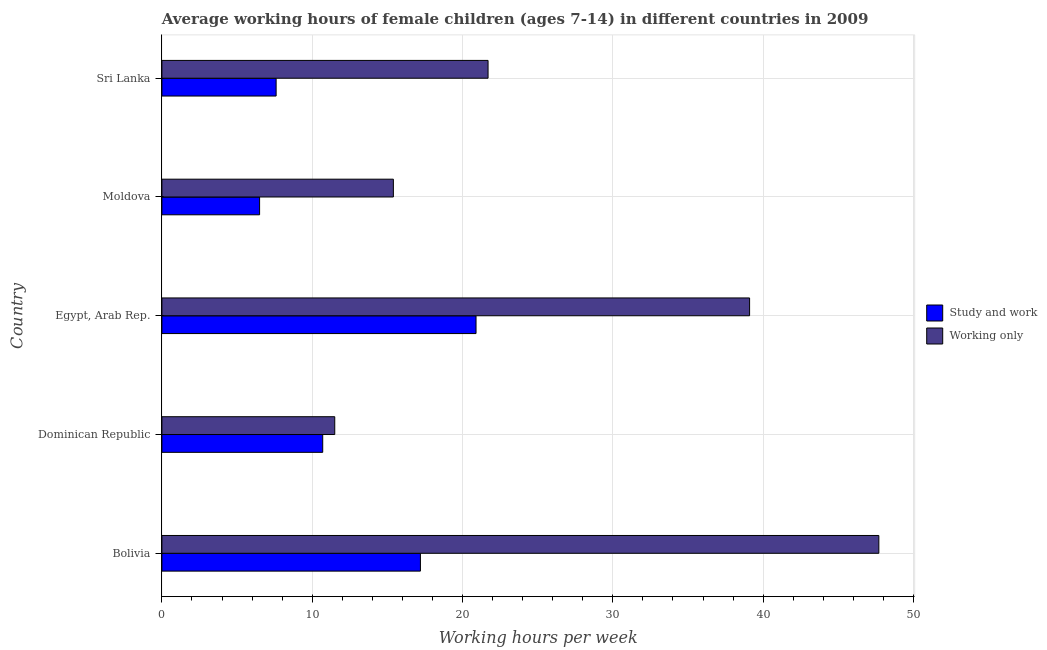How many groups of bars are there?
Give a very brief answer. 5. Are the number of bars per tick equal to the number of legend labels?
Make the answer very short. Yes. Are the number of bars on each tick of the Y-axis equal?
Offer a very short reply. Yes. How many bars are there on the 3rd tick from the bottom?
Your response must be concise. 2. What is the label of the 5th group of bars from the top?
Your response must be concise. Bolivia. What is the average working hour of children involved in study and work in Bolivia?
Make the answer very short. 17.2. Across all countries, what is the maximum average working hour of children involved in only work?
Offer a terse response. 47.7. In which country was the average working hour of children involved in study and work maximum?
Your answer should be very brief. Egypt, Arab Rep. In which country was the average working hour of children involved in only work minimum?
Ensure brevity in your answer.  Dominican Republic. What is the total average working hour of children involved in only work in the graph?
Your response must be concise. 135.4. What is the difference between the average working hour of children involved in only work in Dominican Republic and that in Egypt, Arab Rep.?
Ensure brevity in your answer.  -27.6. What is the difference between the average working hour of children involved in study and work in Sri Lanka and the average working hour of children involved in only work in Bolivia?
Your response must be concise. -40.1. What is the average average working hour of children involved in only work per country?
Make the answer very short. 27.08. What is the difference between the average working hour of children involved in only work and average working hour of children involved in study and work in Sri Lanka?
Your answer should be very brief. 14.1. In how many countries, is the average working hour of children involved in only work greater than 14 hours?
Provide a short and direct response. 4. What is the ratio of the average working hour of children involved in study and work in Moldova to that in Sri Lanka?
Your answer should be compact. 0.85. What is the difference between the highest and the second highest average working hour of children involved in only work?
Offer a very short reply. 8.6. What is the difference between the highest and the lowest average working hour of children involved in only work?
Provide a short and direct response. 36.2. In how many countries, is the average working hour of children involved in study and work greater than the average average working hour of children involved in study and work taken over all countries?
Your answer should be very brief. 2. Is the sum of the average working hour of children involved in study and work in Moldova and Sri Lanka greater than the maximum average working hour of children involved in only work across all countries?
Your response must be concise. No. What does the 2nd bar from the top in Egypt, Arab Rep. represents?
Provide a short and direct response. Study and work. What does the 2nd bar from the bottom in Sri Lanka represents?
Provide a succinct answer. Working only. How many countries are there in the graph?
Your answer should be compact. 5. What is the difference between two consecutive major ticks on the X-axis?
Your answer should be very brief. 10. Are the values on the major ticks of X-axis written in scientific E-notation?
Your answer should be very brief. No. Does the graph contain any zero values?
Provide a succinct answer. No. Where does the legend appear in the graph?
Provide a succinct answer. Center right. How are the legend labels stacked?
Offer a very short reply. Vertical. What is the title of the graph?
Ensure brevity in your answer.  Average working hours of female children (ages 7-14) in different countries in 2009. Does "Commercial service imports" appear as one of the legend labels in the graph?
Ensure brevity in your answer.  No. What is the label or title of the X-axis?
Provide a short and direct response. Working hours per week. What is the label or title of the Y-axis?
Make the answer very short. Country. What is the Working hours per week of Working only in Bolivia?
Provide a succinct answer. 47.7. What is the Working hours per week in Study and work in Dominican Republic?
Give a very brief answer. 10.7. What is the Working hours per week of Study and work in Egypt, Arab Rep.?
Make the answer very short. 20.9. What is the Working hours per week in Working only in Egypt, Arab Rep.?
Ensure brevity in your answer.  39.1. What is the Working hours per week of Study and work in Sri Lanka?
Keep it short and to the point. 7.6. What is the Working hours per week of Working only in Sri Lanka?
Keep it short and to the point. 21.7. Across all countries, what is the maximum Working hours per week of Study and work?
Provide a succinct answer. 20.9. Across all countries, what is the maximum Working hours per week of Working only?
Give a very brief answer. 47.7. Across all countries, what is the minimum Working hours per week of Study and work?
Keep it short and to the point. 6.5. What is the total Working hours per week in Study and work in the graph?
Keep it short and to the point. 62.9. What is the total Working hours per week in Working only in the graph?
Keep it short and to the point. 135.4. What is the difference between the Working hours per week of Study and work in Bolivia and that in Dominican Republic?
Make the answer very short. 6.5. What is the difference between the Working hours per week of Working only in Bolivia and that in Dominican Republic?
Offer a terse response. 36.2. What is the difference between the Working hours per week of Study and work in Bolivia and that in Egypt, Arab Rep.?
Provide a succinct answer. -3.7. What is the difference between the Working hours per week in Working only in Bolivia and that in Egypt, Arab Rep.?
Ensure brevity in your answer.  8.6. What is the difference between the Working hours per week of Working only in Bolivia and that in Moldova?
Provide a short and direct response. 32.3. What is the difference between the Working hours per week of Working only in Bolivia and that in Sri Lanka?
Your answer should be compact. 26. What is the difference between the Working hours per week of Study and work in Dominican Republic and that in Egypt, Arab Rep.?
Your response must be concise. -10.2. What is the difference between the Working hours per week in Working only in Dominican Republic and that in Egypt, Arab Rep.?
Your answer should be very brief. -27.6. What is the difference between the Working hours per week in Study and work in Dominican Republic and that in Moldova?
Provide a short and direct response. 4.2. What is the difference between the Working hours per week of Working only in Dominican Republic and that in Sri Lanka?
Keep it short and to the point. -10.2. What is the difference between the Working hours per week in Study and work in Egypt, Arab Rep. and that in Moldova?
Provide a short and direct response. 14.4. What is the difference between the Working hours per week in Working only in Egypt, Arab Rep. and that in Moldova?
Provide a short and direct response. 23.7. What is the difference between the Working hours per week in Working only in Egypt, Arab Rep. and that in Sri Lanka?
Keep it short and to the point. 17.4. What is the difference between the Working hours per week in Study and work in Moldova and that in Sri Lanka?
Offer a terse response. -1.1. What is the difference between the Working hours per week in Study and work in Bolivia and the Working hours per week in Working only in Dominican Republic?
Provide a succinct answer. 5.7. What is the difference between the Working hours per week in Study and work in Bolivia and the Working hours per week in Working only in Egypt, Arab Rep.?
Your answer should be very brief. -21.9. What is the difference between the Working hours per week of Study and work in Bolivia and the Working hours per week of Working only in Sri Lanka?
Your response must be concise. -4.5. What is the difference between the Working hours per week in Study and work in Dominican Republic and the Working hours per week in Working only in Egypt, Arab Rep.?
Keep it short and to the point. -28.4. What is the difference between the Working hours per week in Study and work in Dominican Republic and the Working hours per week in Working only in Moldova?
Give a very brief answer. -4.7. What is the difference between the Working hours per week in Study and work in Dominican Republic and the Working hours per week in Working only in Sri Lanka?
Keep it short and to the point. -11. What is the difference between the Working hours per week of Study and work in Egypt, Arab Rep. and the Working hours per week of Working only in Moldova?
Provide a short and direct response. 5.5. What is the difference between the Working hours per week of Study and work in Moldova and the Working hours per week of Working only in Sri Lanka?
Provide a succinct answer. -15.2. What is the average Working hours per week in Study and work per country?
Your response must be concise. 12.58. What is the average Working hours per week in Working only per country?
Keep it short and to the point. 27.08. What is the difference between the Working hours per week of Study and work and Working hours per week of Working only in Bolivia?
Your answer should be very brief. -30.5. What is the difference between the Working hours per week in Study and work and Working hours per week in Working only in Dominican Republic?
Your answer should be very brief. -0.8. What is the difference between the Working hours per week in Study and work and Working hours per week in Working only in Egypt, Arab Rep.?
Offer a very short reply. -18.2. What is the difference between the Working hours per week of Study and work and Working hours per week of Working only in Moldova?
Your answer should be compact. -8.9. What is the difference between the Working hours per week of Study and work and Working hours per week of Working only in Sri Lanka?
Offer a terse response. -14.1. What is the ratio of the Working hours per week of Study and work in Bolivia to that in Dominican Republic?
Keep it short and to the point. 1.61. What is the ratio of the Working hours per week of Working only in Bolivia to that in Dominican Republic?
Ensure brevity in your answer.  4.15. What is the ratio of the Working hours per week of Study and work in Bolivia to that in Egypt, Arab Rep.?
Keep it short and to the point. 0.82. What is the ratio of the Working hours per week of Working only in Bolivia to that in Egypt, Arab Rep.?
Keep it short and to the point. 1.22. What is the ratio of the Working hours per week in Study and work in Bolivia to that in Moldova?
Your answer should be compact. 2.65. What is the ratio of the Working hours per week in Working only in Bolivia to that in Moldova?
Give a very brief answer. 3.1. What is the ratio of the Working hours per week of Study and work in Bolivia to that in Sri Lanka?
Your answer should be compact. 2.26. What is the ratio of the Working hours per week of Working only in Bolivia to that in Sri Lanka?
Your answer should be very brief. 2.2. What is the ratio of the Working hours per week of Study and work in Dominican Republic to that in Egypt, Arab Rep.?
Give a very brief answer. 0.51. What is the ratio of the Working hours per week in Working only in Dominican Republic to that in Egypt, Arab Rep.?
Your response must be concise. 0.29. What is the ratio of the Working hours per week of Study and work in Dominican Republic to that in Moldova?
Your response must be concise. 1.65. What is the ratio of the Working hours per week in Working only in Dominican Republic to that in Moldova?
Provide a short and direct response. 0.75. What is the ratio of the Working hours per week of Study and work in Dominican Republic to that in Sri Lanka?
Provide a short and direct response. 1.41. What is the ratio of the Working hours per week in Working only in Dominican Republic to that in Sri Lanka?
Your answer should be compact. 0.53. What is the ratio of the Working hours per week in Study and work in Egypt, Arab Rep. to that in Moldova?
Keep it short and to the point. 3.22. What is the ratio of the Working hours per week of Working only in Egypt, Arab Rep. to that in Moldova?
Ensure brevity in your answer.  2.54. What is the ratio of the Working hours per week in Study and work in Egypt, Arab Rep. to that in Sri Lanka?
Your answer should be compact. 2.75. What is the ratio of the Working hours per week in Working only in Egypt, Arab Rep. to that in Sri Lanka?
Ensure brevity in your answer.  1.8. What is the ratio of the Working hours per week in Study and work in Moldova to that in Sri Lanka?
Your answer should be very brief. 0.86. What is the ratio of the Working hours per week of Working only in Moldova to that in Sri Lanka?
Provide a succinct answer. 0.71. What is the difference between the highest and the second highest Working hours per week in Study and work?
Provide a short and direct response. 3.7. What is the difference between the highest and the lowest Working hours per week of Study and work?
Ensure brevity in your answer.  14.4. What is the difference between the highest and the lowest Working hours per week of Working only?
Your answer should be very brief. 36.2. 